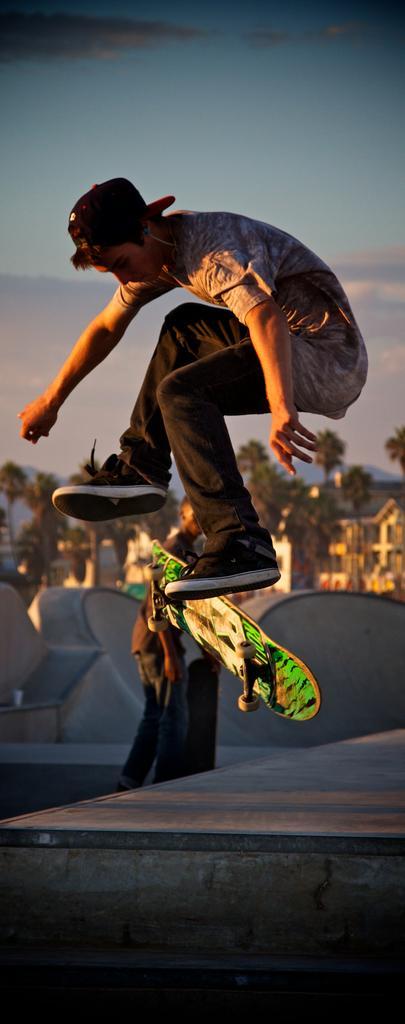Describe this image in one or two sentences. In this image I can see a person wearing black pant, black hat, black and white cap is flying in the air and I can see a skateboard which is black, white and green in color below him. In the background I can see a person standing, the skating track, few buildings, few trees , few mountains and the sky. 